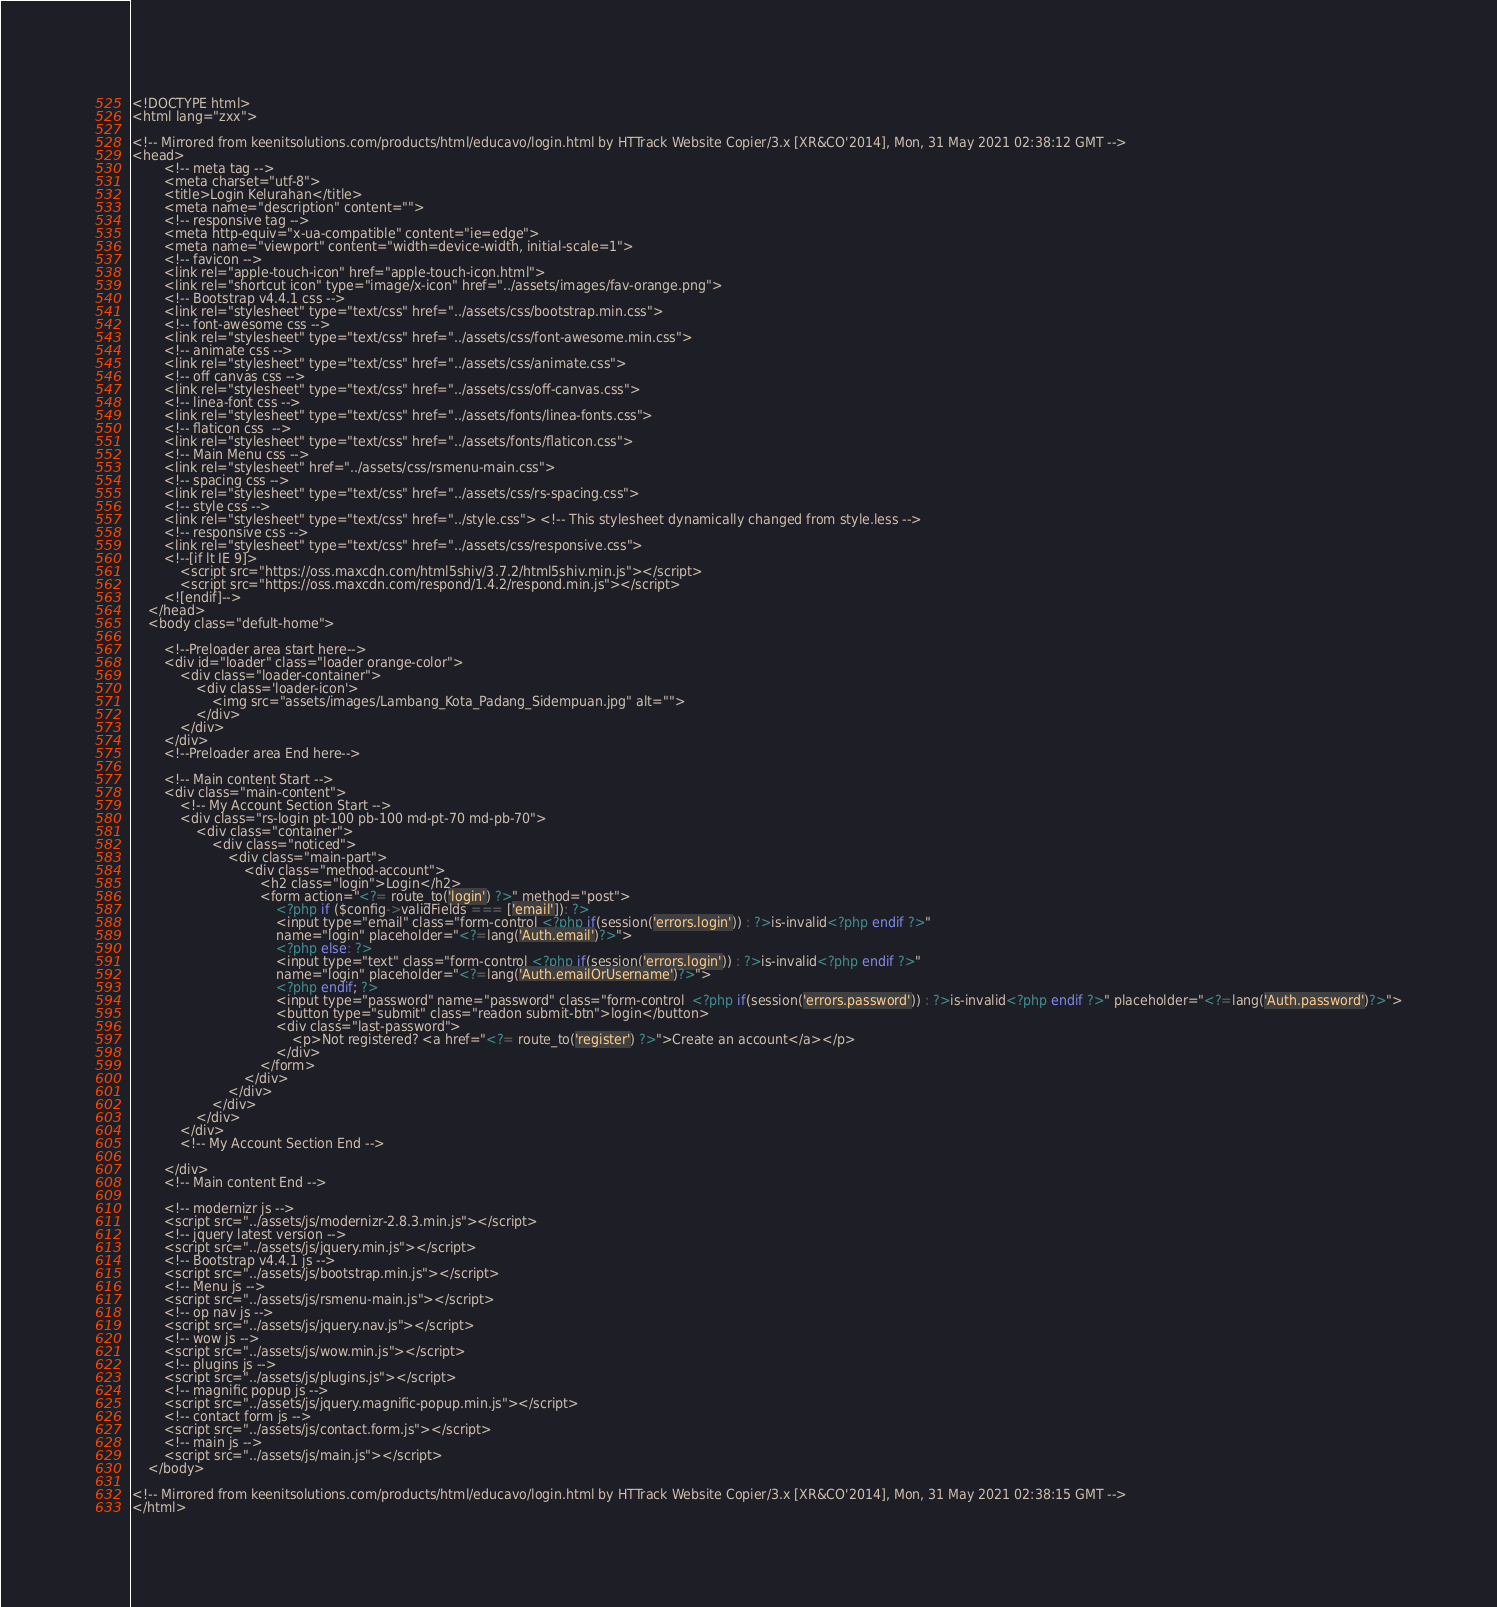Convert code to text. <code><loc_0><loc_0><loc_500><loc_500><_PHP_>
<!DOCTYPE html>
<html lang="zxx">
    
<!-- Mirrored from keenitsolutions.com/products/html/educavo/login.html by HTTrack Website Copier/3.x [XR&CO'2014], Mon, 31 May 2021 02:38:12 GMT -->
<head> 
        <!-- meta tag -->
        <meta charset="utf-8">
        <title>Login Kelurahan</title>
        <meta name="description" content="">
        <!-- responsive tag -->
        <meta http-equiv="x-ua-compatible" content="ie=edge">
        <meta name="viewport" content="width=device-width, initial-scale=1">
        <!-- favicon -->
        <link rel="apple-touch-icon" href="apple-touch-icon.html">
        <link rel="shortcut icon" type="image/x-icon" href="../assets/images/fav-orange.png">
        <!-- Bootstrap v4.4.1 css -->
        <link rel="stylesheet" type="text/css" href="../assets/css/bootstrap.min.css">
        <!-- font-awesome css -->
        <link rel="stylesheet" type="text/css" href="../assets/css/font-awesome.min.css">
        <!-- animate css -->
        <link rel="stylesheet" type="text/css" href="../assets/css/animate.css">
        <!-- off canvas css -->
        <link rel="stylesheet" type="text/css" href="../assets/css/off-canvas.css">
        <!-- linea-font css -->
        <link rel="stylesheet" type="text/css" href="../assets/fonts/linea-fonts.css">
        <!-- flaticon css  -->
        <link rel="stylesheet" type="text/css" href="../assets/fonts/flaticon.css">
        <!-- Main Menu css -->
        <link rel="stylesheet" href="../assets/css/rsmenu-main.css">
        <!-- spacing css -->
        <link rel="stylesheet" type="text/css" href="../assets/css/rs-spacing.css">
        <!-- style css -->
        <link rel="stylesheet" type="text/css" href="../style.css"> <!-- This stylesheet dynamically changed from style.less -->
        <!-- responsive css -->
        <link rel="stylesheet" type="text/css" href="../assets/css/responsive.css">
        <!--[if lt IE 9]>
            <script src="https://oss.maxcdn.com/html5shiv/3.7.2/html5shiv.min.js"></script>
            <script src="https://oss.maxcdn.com/respond/1.4.2/respond.min.js"></script>
        <![endif]-->
    </head>
    <body class="defult-home">
        
        <!--Preloader area start here-->
        <div id="loader" class="loader orange-color">
            <div class="loader-container">
                <div class='loader-icon'>
                    <img src="assets/images/Lambang_Kota_Padang_Sidempuan.jpg" alt="">
                </div>
            </div>
        </div>
        <!--Preloader area End here-->

		<!-- Main content Start -->
        <div class="main-content">
    		<!-- My Account Section Start -->
    		<div class="rs-login pt-100 pb-100 md-pt-70 md-pb-70">
                <div class="container">
                    <div class="noticed">
                        <div class="main-part">                           
                            <div class="method-account">
                                <h2 class="login">Login</h2>
                                <form action="<?= route_to('login') ?>" method="post">
                                    <?php if ($config->validFields === ['email']): ?>
                                    <input type="email" class="form-control <?php if(session('errors.login')) : ?>is-invalid<?php endif ?>"
                                    name="login" placeholder="<?=lang('Auth.email')?>">
                                    <?php else: ?>
                                    <input type="text" class="form-control <?php if(session('errors.login')) : ?>is-invalid<?php endif ?>"
								    name="login" placeholder="<?=lang('Auth.emailOrUsername')?>">
                                    <?php endif; ?>
                                    <input type="password" name="password" class="form-control  <?php if(session('errors.password')) : ?>is-invalid<?php endif ?>" placeholder="<?=lang('Auth.password')?>">
                                    <button type="submit" class="readon submit-btn">login</button>
                                    <div class="last-password">
                                        <p>Not registered? <a href="<?= route_to('register') ?>">Create an account</a></p>
                                    </div>
                                </form>
                            </div>
                        </div>
                    </div>
                </div>
            </div>
            <!-- My Account Section End -->  

        </div> 
        <!-- Main content End --> 

        <!-- modernizr js -->
        <script src="../assets/js/modernizr-2.8.3.min.js"></script>
        <!-- jquery latest version -->
        <script src="../assets/js/jquery.min.js"></script>
        <!-- Bootstrap v4.4.1 js -->
        <script src="../assets/js/bootstrap.min.js"></script>
        <!-- Menu js -->
        <script src="../assets/js/rsmenu-main.js"></script> 
        <!-- op nav js -->
        <script src="../assets/js/jquery.nav.js"></script>
        <!-- wow js -->
        <script src="../assets/js/wow.min.js"></script>     
        <!-- plugins js -->
        <script src="../assets/js/plugins.js"></script>
        <!-- magnific popup js -->
        <script src="../assets/js/jquery.magnific-popup.min.js"></script>  
        <!-- contact form js -->
        <script src="../assets/js/contact.form.js"></script>
        <!-- main js -->
        <script src="../assets/js/main.js"></script>
    </body>

<!-- Mirrored from keenitsolutions.com/products/html/educavo/login.html by HTTrack Website Copier/3.x [XR&CO'2014], Mon, 31 May 2021 02:38:15 GMT -->
</html></code> 